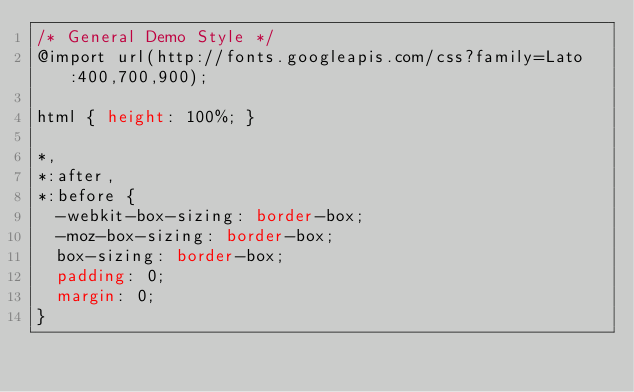<code> <loc_0><loc_0><loc_500><loc_500><_CSS_>/* General Demo Style */
@import url(http://fonts.googleapis.com/css?family=Lato:400,700,900);

html { height: 100%; }

*,
*:after,
*:before {
	-webkit-box-sizing: border-box;
	-moz-box-sizing: border-box;
	box-sizing: border-box;
	padding: 0;
	margin: 0;
}
</code> 